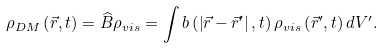Convert formula to latex. <formula><loc_0><loc_0><loc_500><loc_500>\rho _ { D M } \left ( \vec { r } , t \right ) = \widehat { B } \rho _ { v i s } = \int b \left ( \left | \vec { r } - \vec { r } ^ { \prime } \right | , t \right ) \rho _ { v i s } \left ( \vec { r } ^ { \prime } , t \right ) d V ^ { \prime } .</formula> 